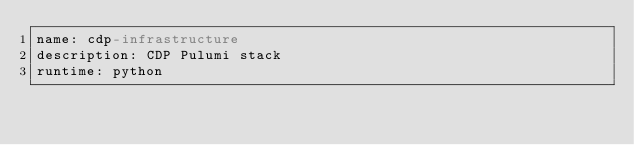<code> <loc_0><loc_0><loc_500><loc_500><_YAML_>name: cdp-infrastructure
description: CDP Pulumi stack
runtime: python
</code> 